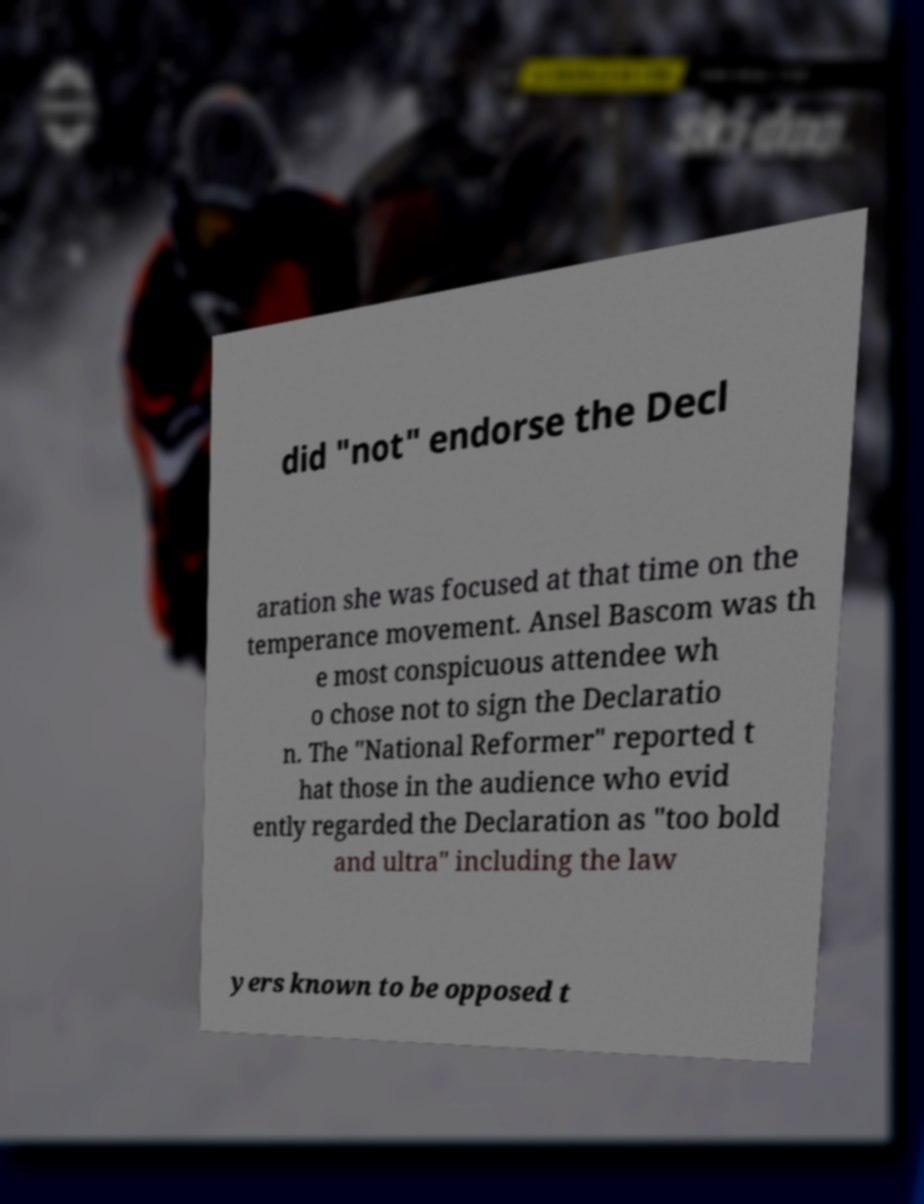Please identify and transcribe the text found in this image. did "not" endorse the Decl aration she was focused at that time on the temperance movement. Ansel Bascom was th e most conspicuous attendee wh o chose not to sign the Declaratio n. The "National Reformer" reported t hat those in the audience who evid ently regarded the Declaration as "too bold and ultra" including the law yers known to be opposed t 